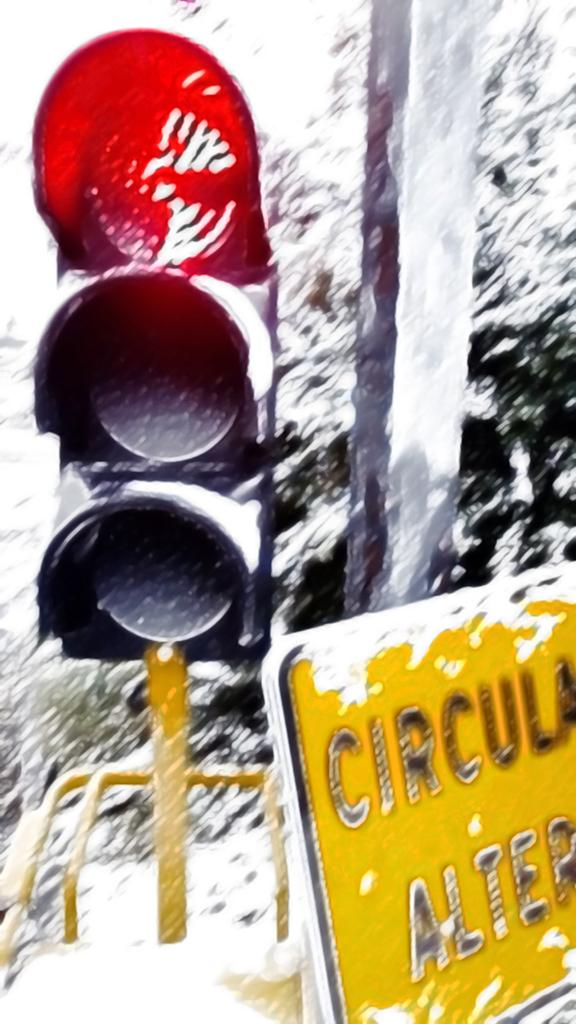<image>
Write a terse but informative summary of the picture. a stop sign in the snow with a yellow sign nearby that says circula on it. 